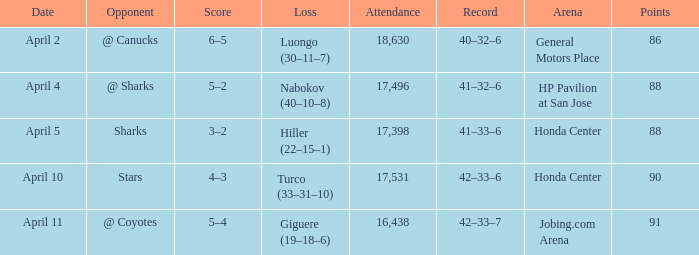Which attendance records have over 90 points? 16438.0. 